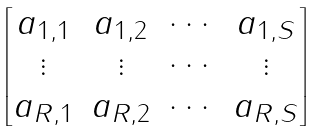Convert formula to latex. <formula><loc_0><loc_0><loc_500><loc_500>\begin{bmatrix} a _ { 1 , 1 } & a _ { 1 , 2 } & \cdots & a _ { 1 , S } \\ \vdots & \vdots & \cdots & \vdots \\ a _ { R , 1 } & a _ { R , 2 } & \cdots & a _ { R , S } \end{bmatrix}</formula> 